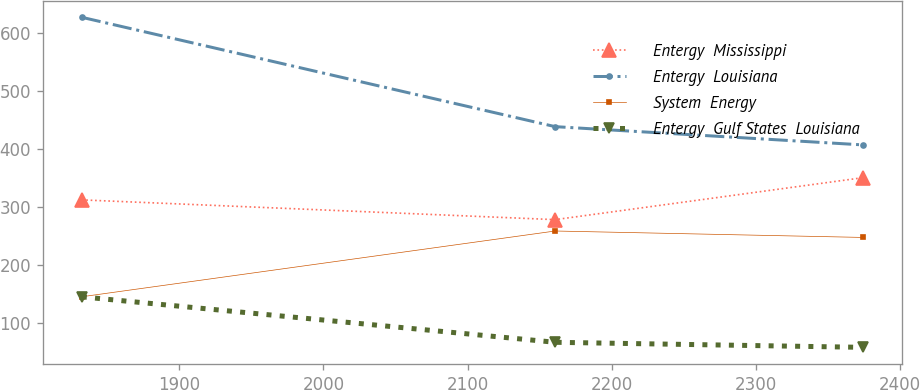Convert chart. <chart><loc_0><loc_0><loc_500><loc_500><line_chart><ecel><fcel>Entergy  Mississippi<fcel>Entergy  Louisiana<fcel>System  Energy<fcel>Entergy  Gulf States  Louisiana<nl><fcel>1832.36<fcel>311.77<fcel>626.69<fcel>144.69<fcel>144.54<nl><fcel>2160.79<fcel>277.68<fcel>438.09<fcel>258.09<fcel>66.11<nl><fcel>2374.69<fcel>350.19<fcel>406.54<fcel>246.98<fcel>57.4<nl></chart> 